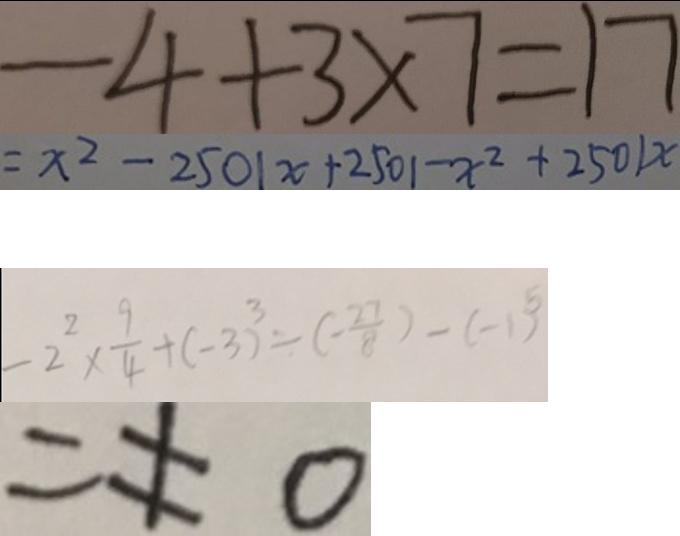<formula> <loc_0><loc_0><loc_500><loc_500>- 4 + 3 \times 7 = 1 7 
 = x ^ { 2 } - 2 5 0 1 x + 2 5 0 1 - x ^ { 2 } + 2 5 0 1 x 
 - 2 ^ { 2 } \times \frac { 9 } { 4 } + ( - 3 ) ^ { 3 } \div ( - \frac { 2 7 } { 8 } ) - ( - 1 ) ^ { 5 } 
 = \neq 0</formula> 